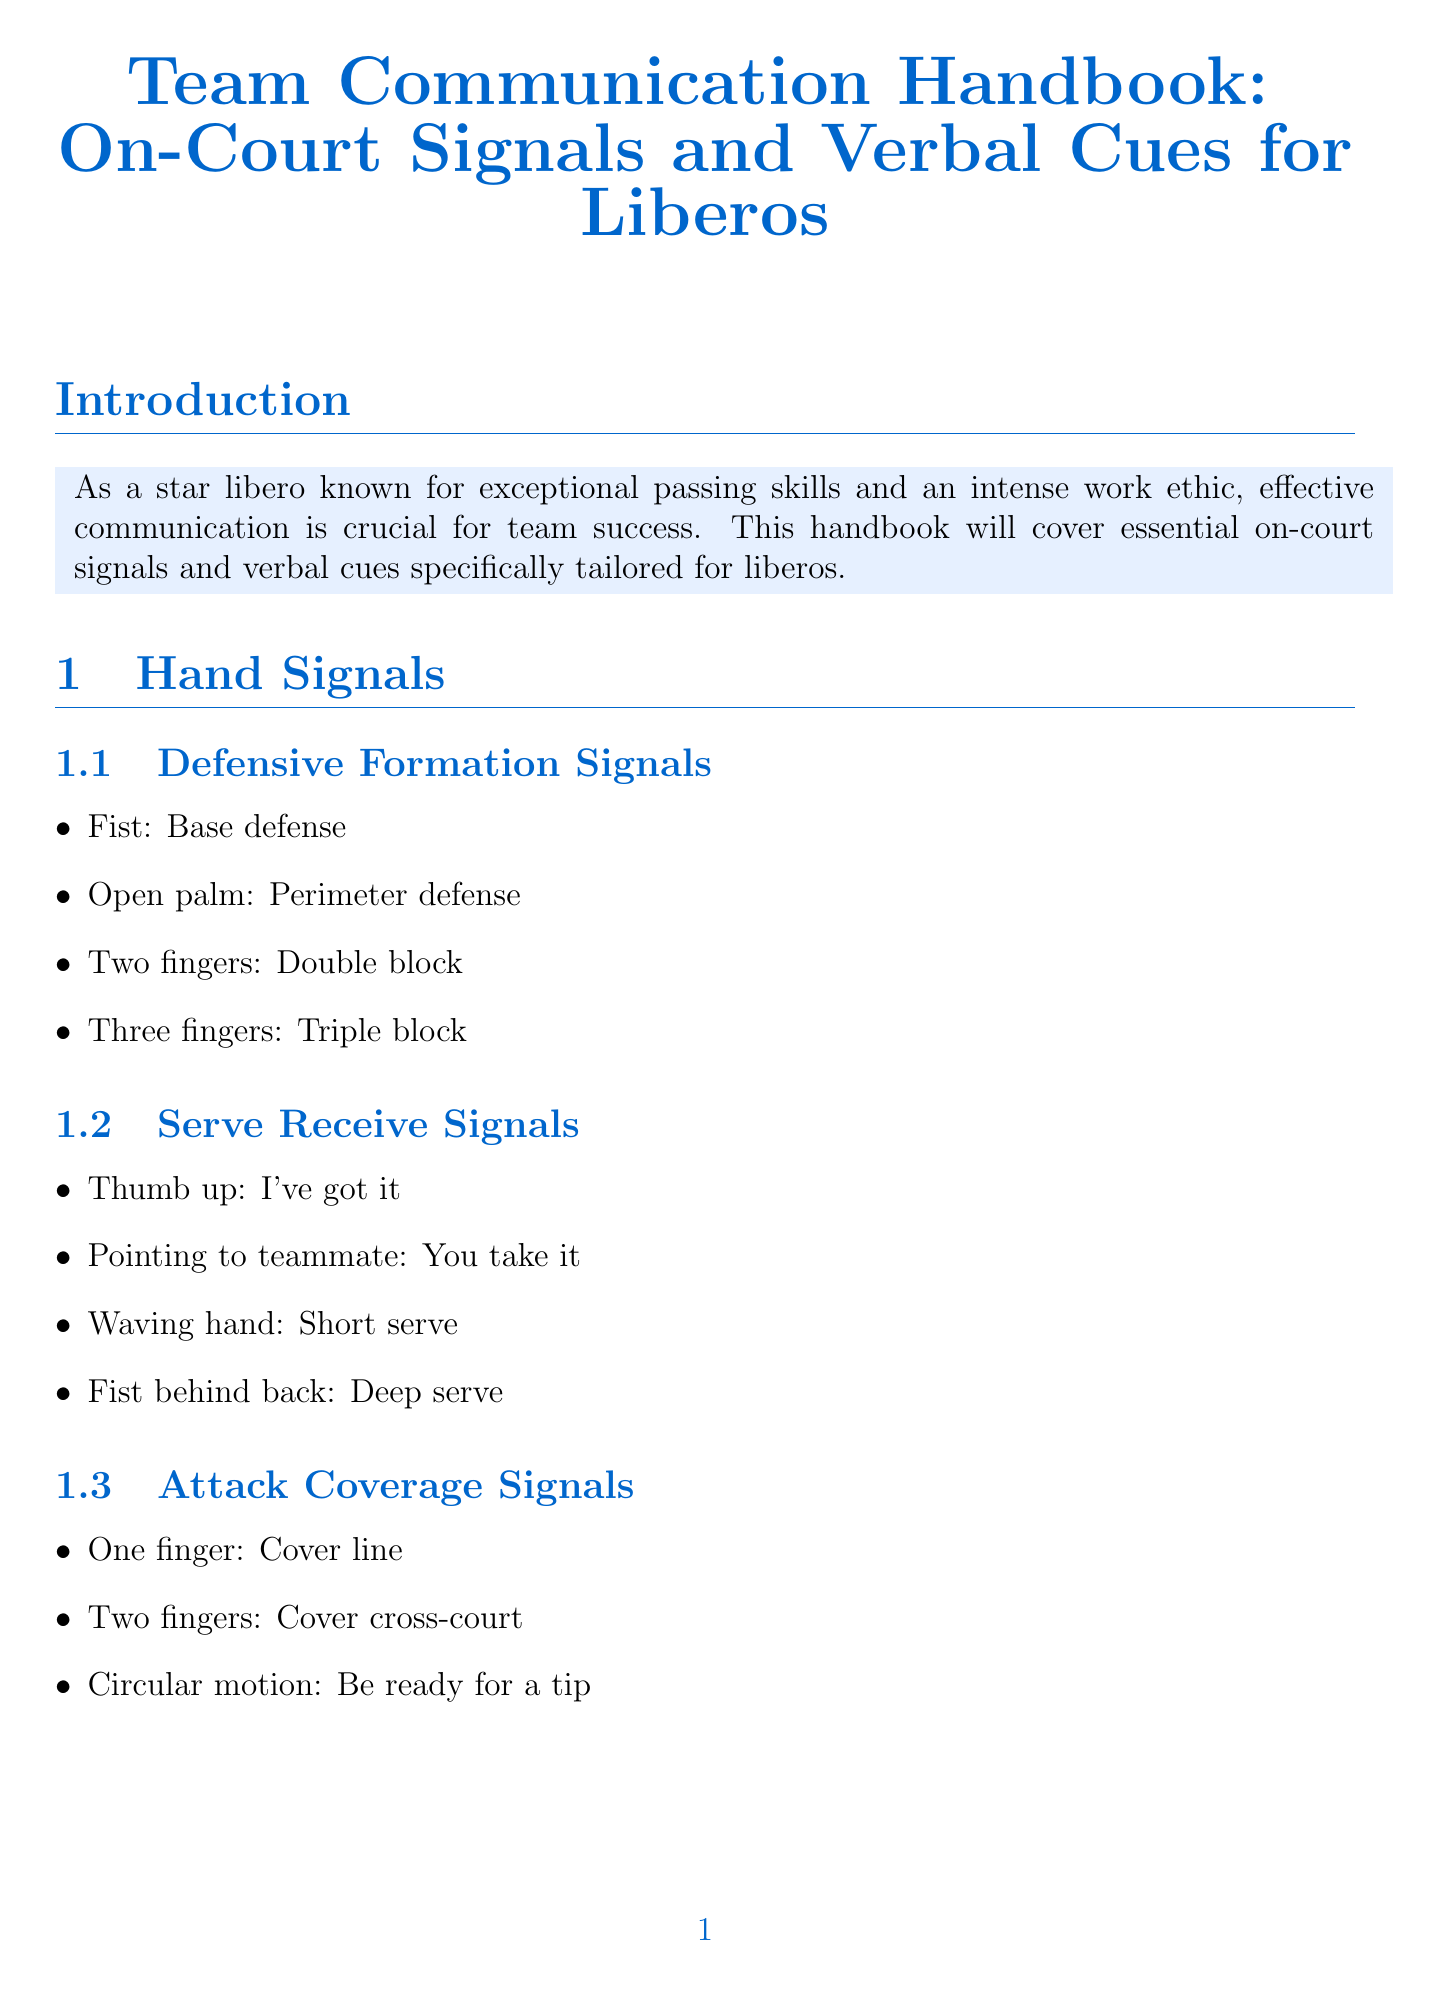What is the title of the handbook? The title is found at the top of the document, summarizing its focus on communication for liberos.
Answer: Team Communication Handbook: On-Court Signals and Verbal Cues for Liberos How many hand signals are listed for defensive formation? The number of hand signals is detailed in the respective subsection about defensive formation signals.
Answer: 4 What does a fist symbol represent in defensive formation signals? The meaning of the fist symbol is described in the hand signals section under defensive formation signals.
Answer: Base defense What verbal cue indicates a short serve? The specific verbal cue is found in the serve receive calls subsection.
Answer: Short Who is mentioned in the case study of the USA Women's National Team? The individuals highlighted in the case study are stated in the case studies section regarding team communication.
Answer: Justine Wong-Orantes What is the purpose of the “Pepper Communication” drill? The intention of this drill is elaborated in the communication drills section.
Answer: Reinforce habits How many defensive calls are listed? The total number of defensive calls is specified in the verbal cues section under defensive calls.
Answer: 4 What communication term indicates no blockers on the opponent's side? The term is explained in the section focusing on communication with setters.
Answer: Free What is the primary focus of the handbook? The main focus is articulated in the introduction, emphasizing the importance of the subject matter for liberos.
Answer: Effective communication 